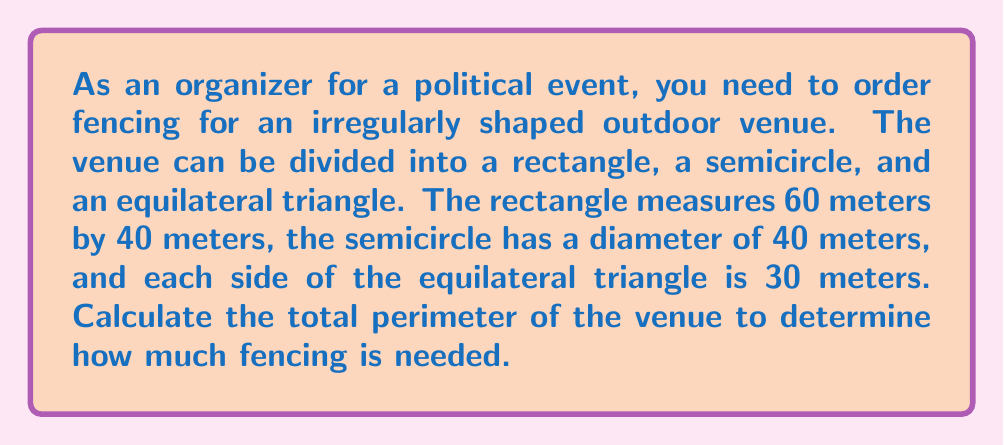Can you answer this question? Let's break this down step-by-step:

1. Rectangle perimeter:
   $$ P_{rectangle} = 2(l + w) = 2(60 + 40) = 2(100) = 200 \text{ meters} $$

2. Semicircle perimeter:
   The semicircle is half of a full circle, so we need half the circumference plus the diameter.
   $$ P_{semicircle} = \frac{1}{2} \cdot 2\pi r + d = \pi r + d = \pi \cdot 20 + 40 \approx 102.83 \text{ meters} $$

3. Equilateral triangle perimeter:
   $$ P_{triangle} = 3s = 3 \cdot 30 = 90 \text{ meters} $$

4. Total perimeter:
   $$ P_{total} = P_{rectangle} + P_{semicircle} + P_{triangle} $$
   $$ P_{total} = 200 + 102.83 + 90 = 392.83 \text{ meters} $$

[asy]
unitsize(2mm);
fill((0,0)--(60,0)--(60,40)--(0,40)--cycle,lightgray);
fill(arc((60,20),20,90,270),lightgray);
fill((0,40)--(15,40+15*sqrt(3))--(30,40)--cycle,lightgray);
draw((0,0)--(60,0)--(60,40)--(0,40)--cycle);
draw(arc((60,20),20,90,270));
draw((0,40)--(15,40+15*sqrt(3))--(30,40));
label("60m",(30,0),S);
label("40m",(0,20),W);
label("40m",(60,20),E);
label("30m",(15,40),N);
[/asy]
Answer: 392.83 meters 